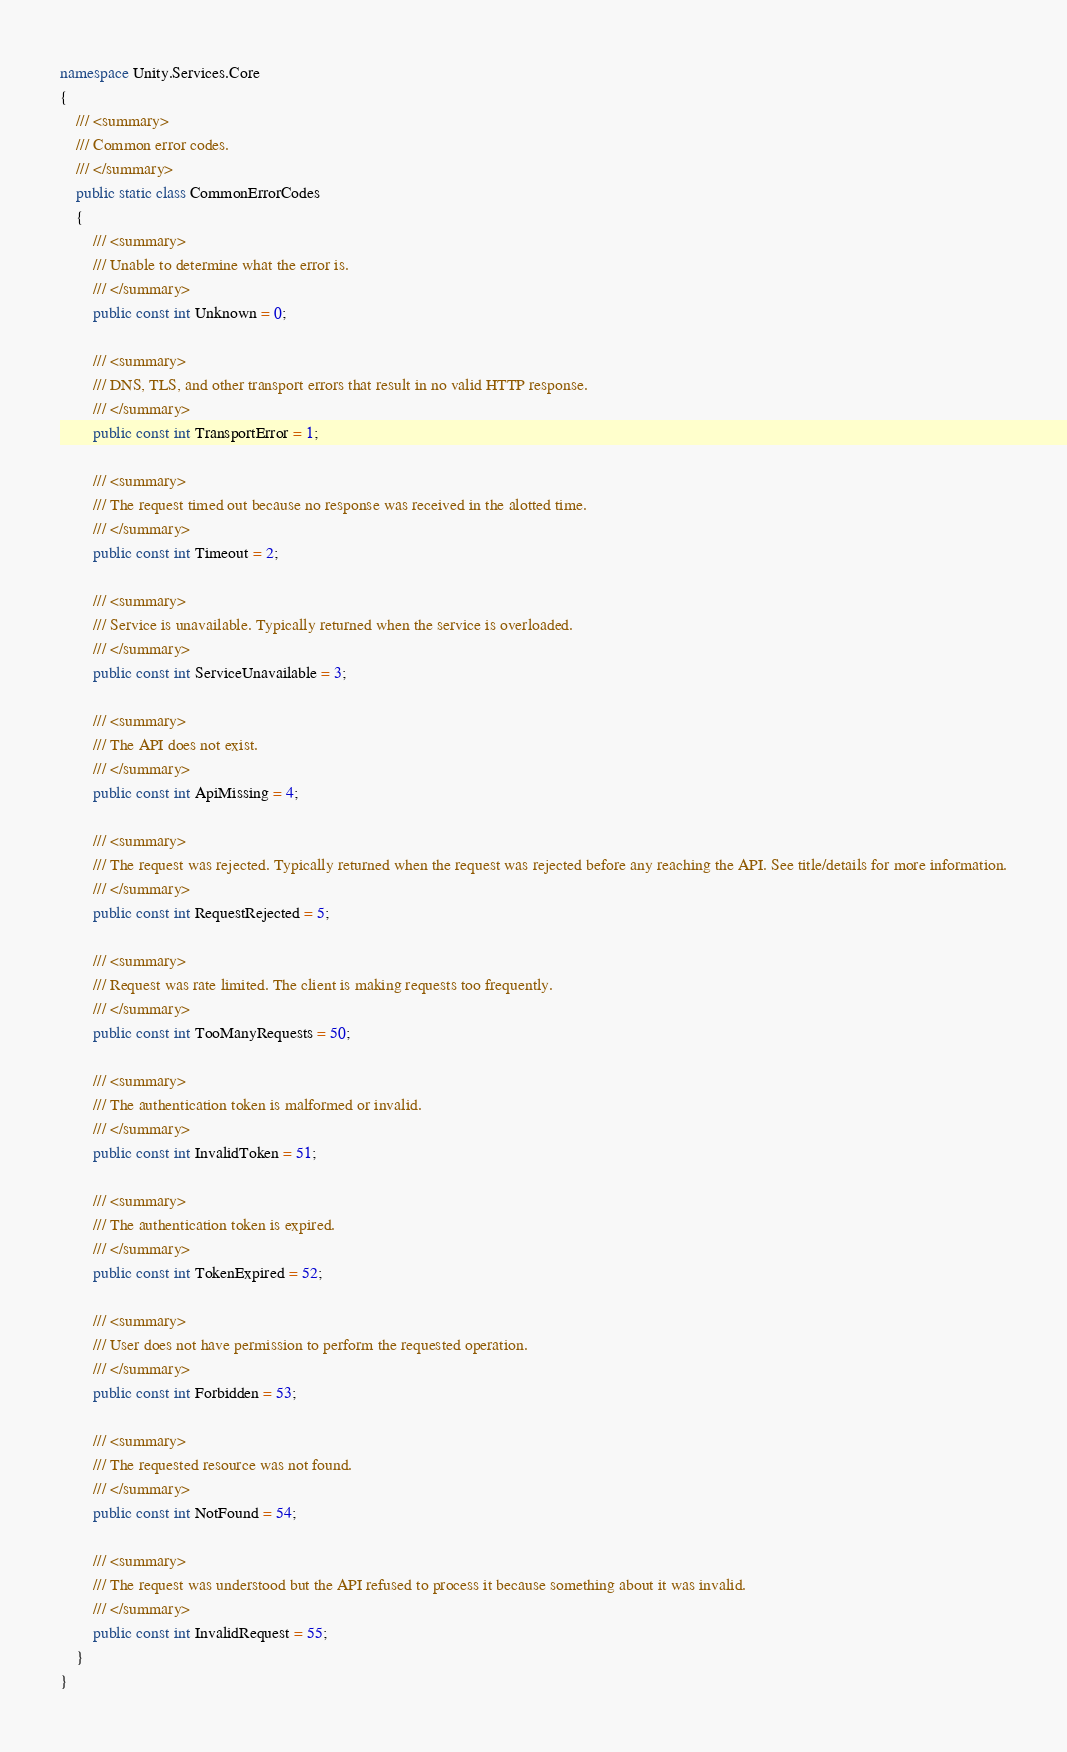Convert code to text. <code><loc_0><loc_0><loc_500><loc_500><_C#_>namespace Unity.Services.Core
{
    /// <summary>
    /// Common error codes.
    /// </summary>
    public static class CommonErrorCodes
    {
        /// <summary>
        /// Unable to determine what the error is.
        /// </summary>
        public const int Unknown = 0;

        /// <summary>
        /// DNS, TLS, and other transport errors that result in no valid HTTP response.
        /// </summary>
        public const int TransportError = 1;

        /// <summary>
        /// The request timed out because no response was received in the alotted time.
        /// </summary>
        public const int Timeout = 2;

        /// <summary>
        /// Service is unavailable. Typically returned when the service is overloaded.
        /// </summary>
        public const int ServiceUnavailable = 3;

        /// <summary>
        /// The API does not exist.
        /// </summary>
        public const int ApiMissing = 4;

        /// <summary>
        /// The request was rejected. Typically returned when the request was rejected before any reaching the API. See title/details for more information.
        /// </summary>
        public const int RequestRejected = 5;

        /// <summary>
        /// Request was rate limited. The client is making requests too frequently.
        /// </summary>
        public const int TooManyRequests = 50;

        /// <summary>
        /// The authentication token is malformed or invalid.
        /// </summary>
        public const int InvalidToken = 51;

        /// <summary>
        /// The authentication token is expired.
        /// </summary>
        public const int TokenExpired = 52;

        /// <summary>
        /// User does not have permission to perform the requested operation.
        /// </summary>
        public const int Forbidden = 53;

        /// <summary>
        /// The requested resource was not found.
        /// </summary>
        public const int NotFound = 54;

        /// <summary>
        /// The request was understood but the API refused to process it because something about it was invalid.
        /// </summary>
        public const int InvalidRequest = 55;
    }
}
</code> 